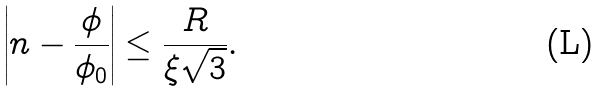Convert formula to latex. <formula><loc_0><loc_0><loc_500><loc_500>\left | n - \frac { \phi } { \phi _ { 0 } } \right | \leq \frac { R } { \xi \sqrt { 3 } } .</formula> 